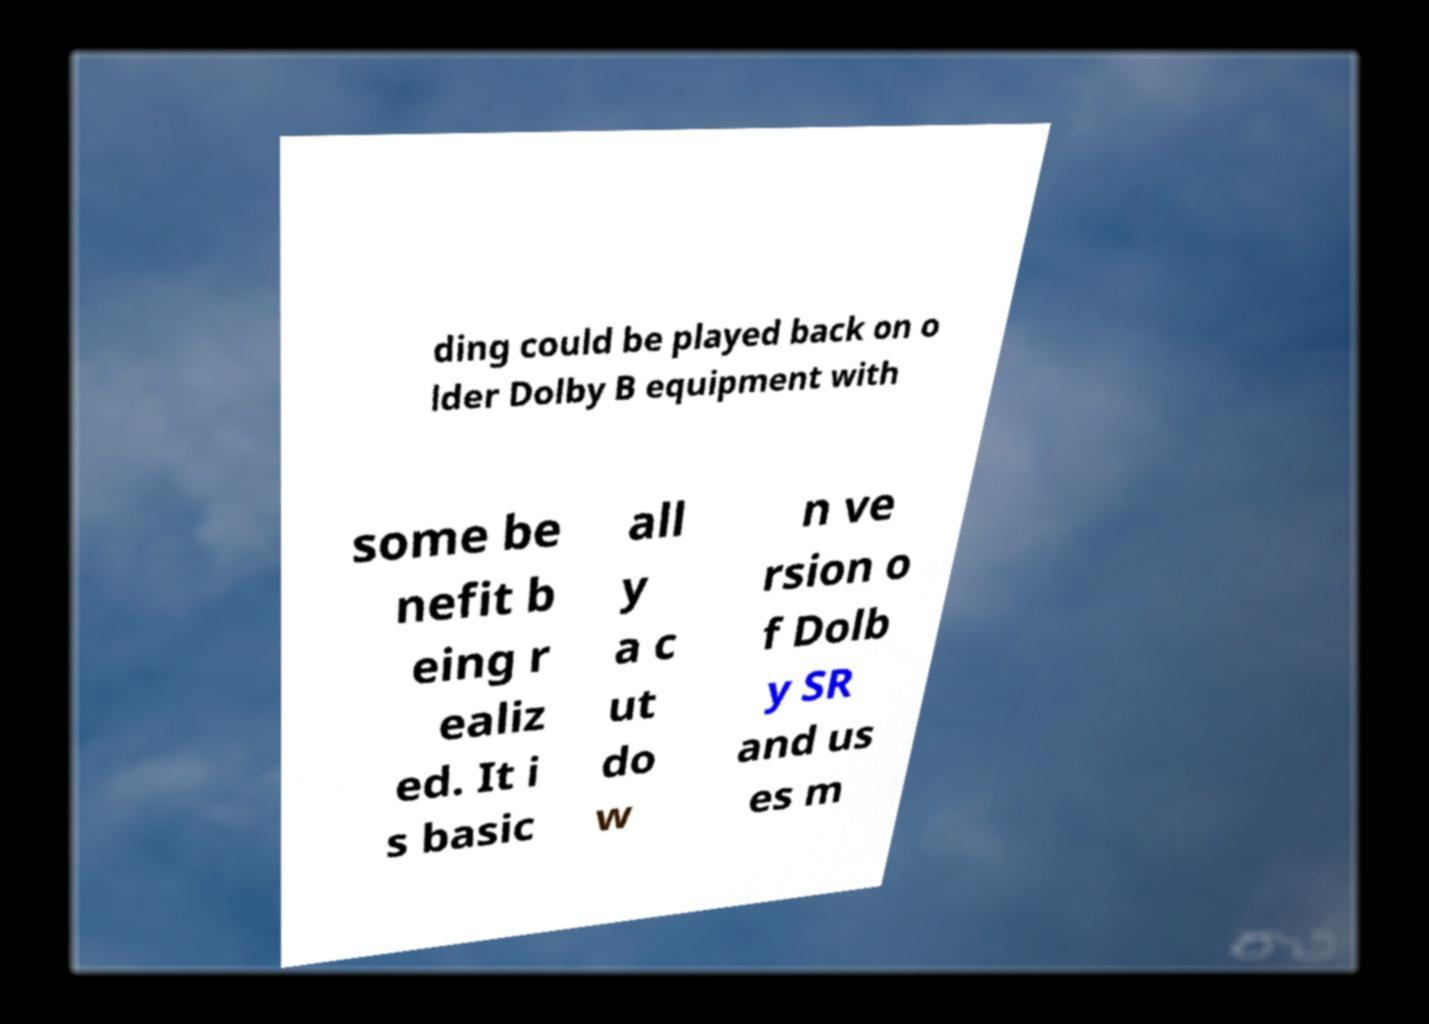For documentation purposes, I need the text within this image transcribed. Could you provide that? ding could be played back on o lder Dolby B equipment with some be nefit b eing r ealiz ed. It i s basic all y a c ut do w n ve rsion o f Dolb y SR and us es m 